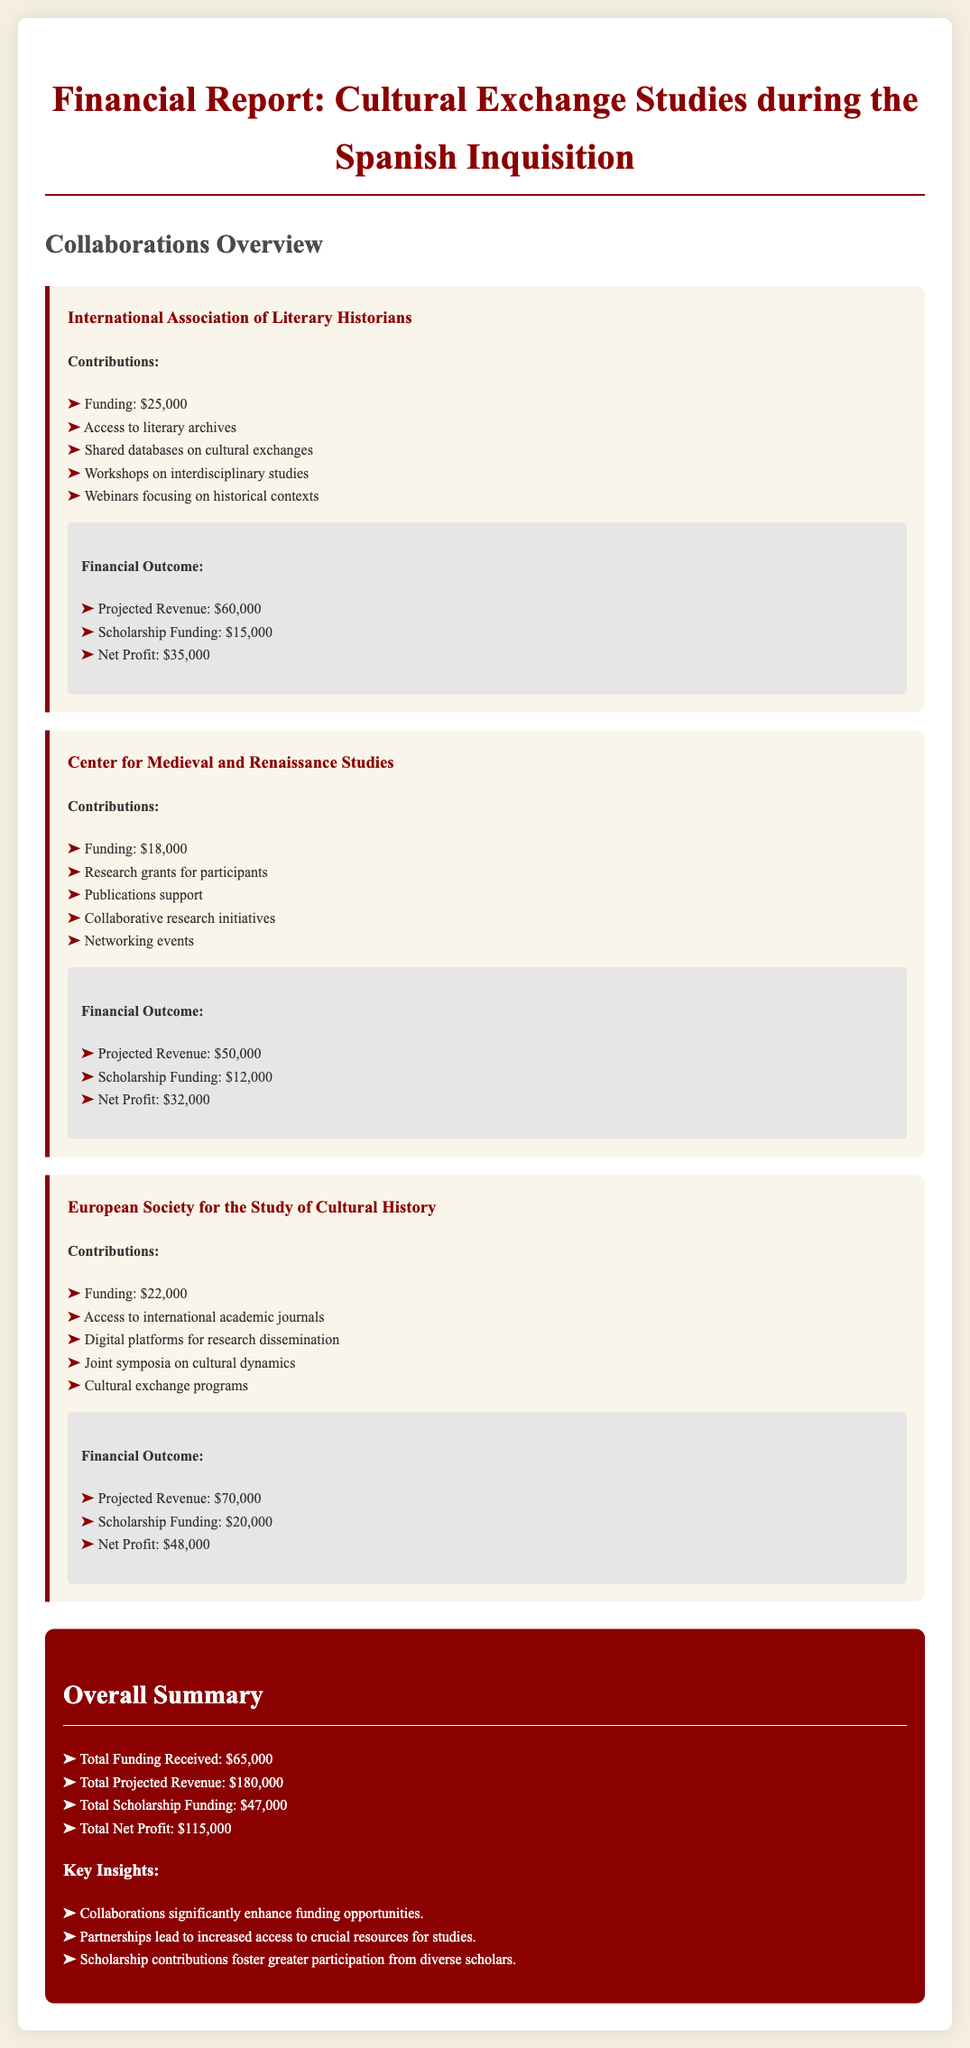What is the funding received from the International Association of Literary Historians? The funding listed for the International Association of Literary Historians in the document is $25,000.
Answer: $25,000 What is the total projected revenue? The total projected revenue is provided in the summary and is the sum of the projected revenues from all collaborations, which totals $180,000.
Answer: $180,000 What is the net profit from the European Society for the Study of Cultural History? The net profit for the European Society for the Study of Cultural History can be found in the financial outcome section for this collaboration, which is $48,000.
Answer: $48,000 How much scholarship funding was provided by the Center for Medieval and Renaissance Studies? The scholarship funding provided by the Center for Medieval and Renaissance Studies is stated as $12,000 in the collaboration's financial outcome.
Answer: $12,000 What key insight highlights the importance of collaborations? One key insight is that collaborations significantly enhance funding opportunities, indicating their importance in the financial report.
Answer: Collaborations significantly enhance funding opportunities What is the total scholarship funding across all collaborations? The total scholarship funding is the sum of all scholarship funding amounts detailed in the document, which equals $47,000.
Answer: $47,000 What is the contribution from the European Society for the Study of Cultural History? The contribution from the European Society for the Study of Cultural History listed in the document is $22,000.
Answer: $22,000 What are the total net profits from all collaborations? The total net profit is found in the summary section, which states that the total is $115,000.
Answer: $115,000 How many organizations collaborated on the cultural exchange studies? There are three organizations mentioned in the collaborations segment of the document.
Answer: Three organizations 